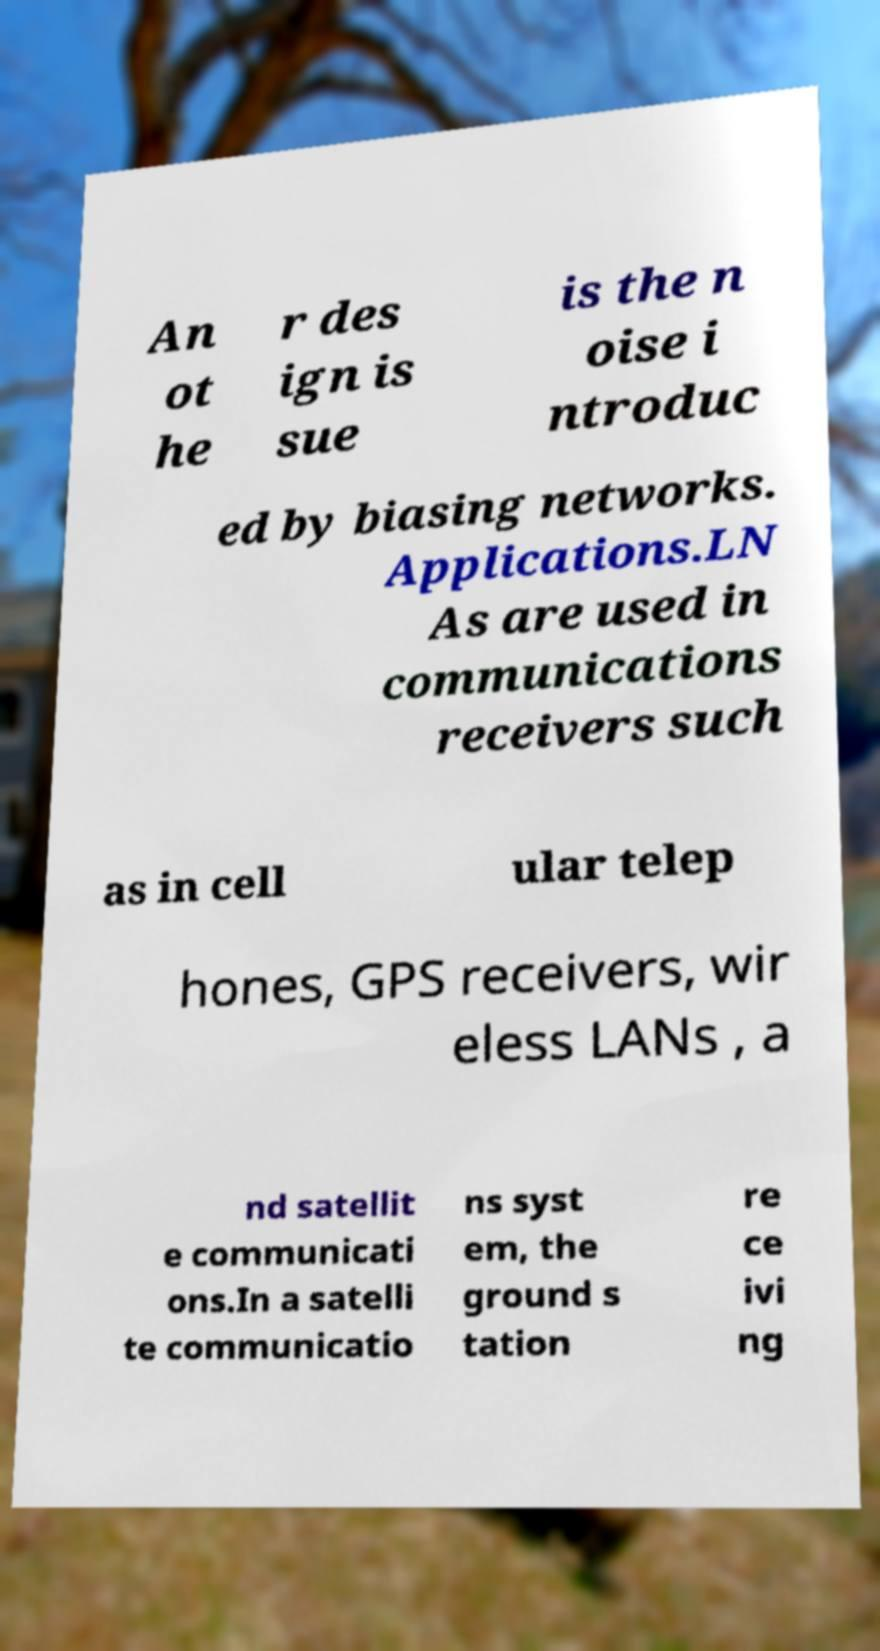For documentation purposes, I need the text within this image transcribed. Could you provide that? An ot he r des ign is sue is the n oise i ntroduc ed by biasing networks. Applications.LN As are used in communications receivers such as in cell ular telep hones, GPS receivers, wir eless LANs , a nd satellit e communicati ons.In a satelli te communicatio ns syst em, the ground s tation re ce ivi ng 